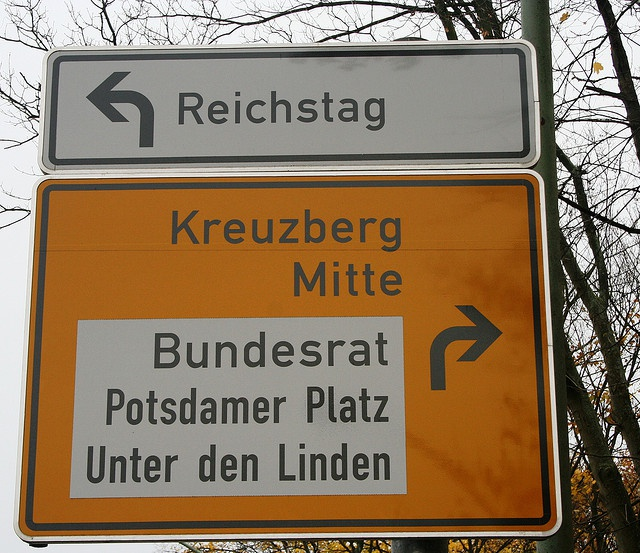Describe the objects in this image and their specific colors. I can see various objects in this image with different colors. 